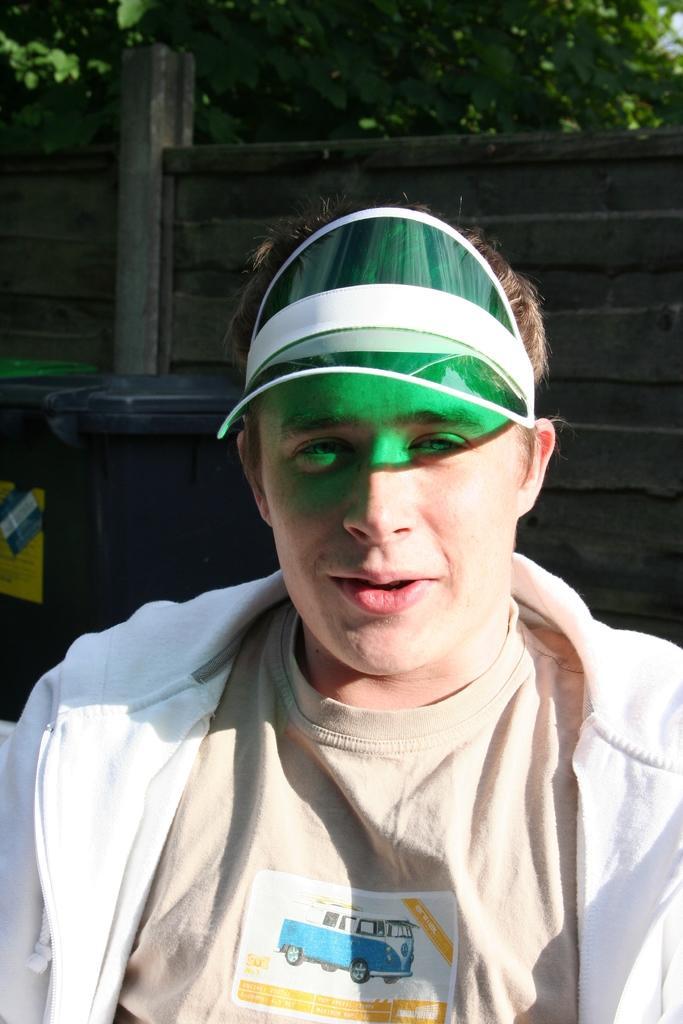How would you summarize this image in a sentence or two? In this picture I can see a man is sitting and I can see a dustbin and a wooden wall in the back and I can see tree and man is wearing a cap on his head. 